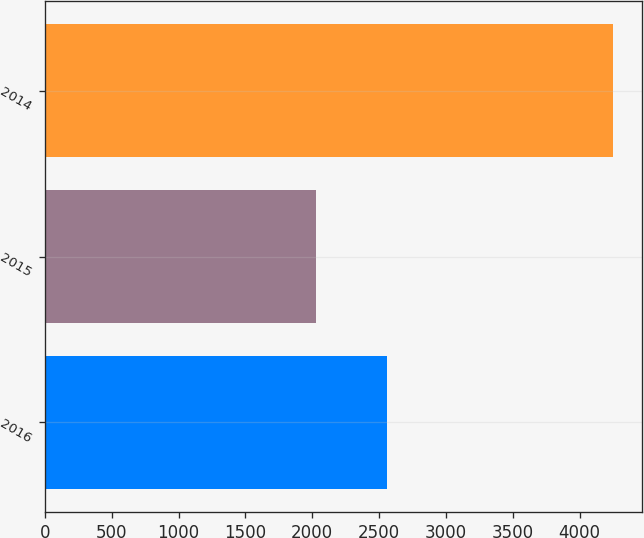Convert chart. <chart><loc_0><loc_0><loc_500><loc_500><bar_chart><fcel>2016<fcel>2015<fcel>2014<nl><fcel>2561<fcel>2026<fcel>4253<nl></chart> 